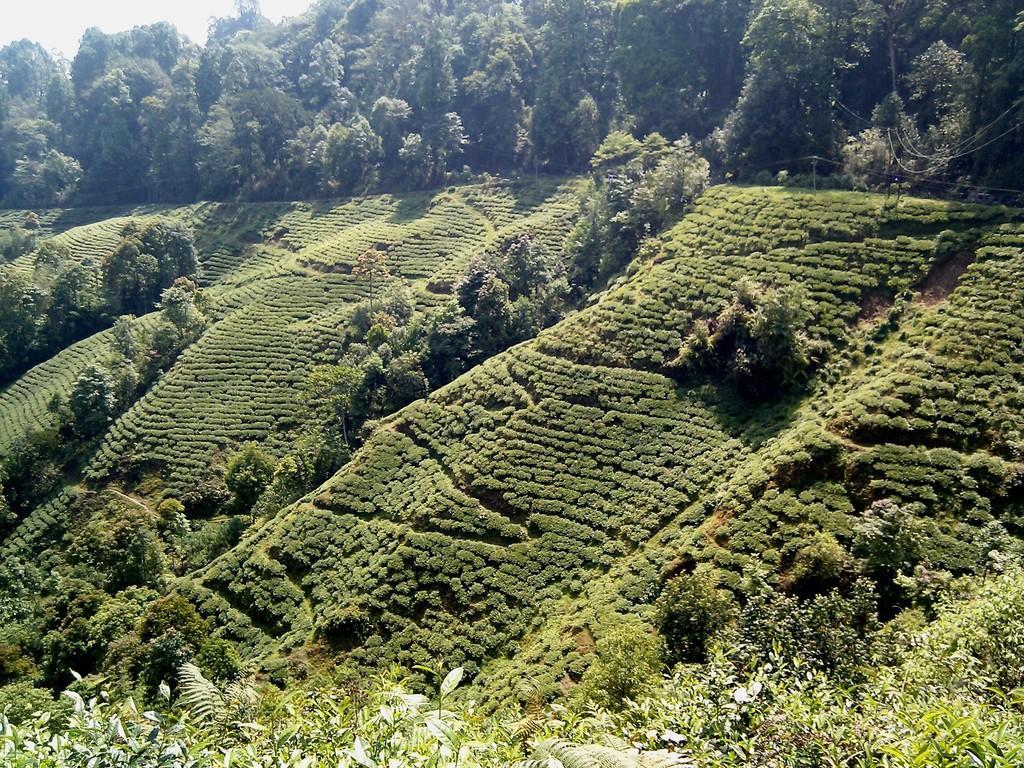In one or two sentences, can you explain what this image depicts? In this picture there is greenery around the area of the image. 